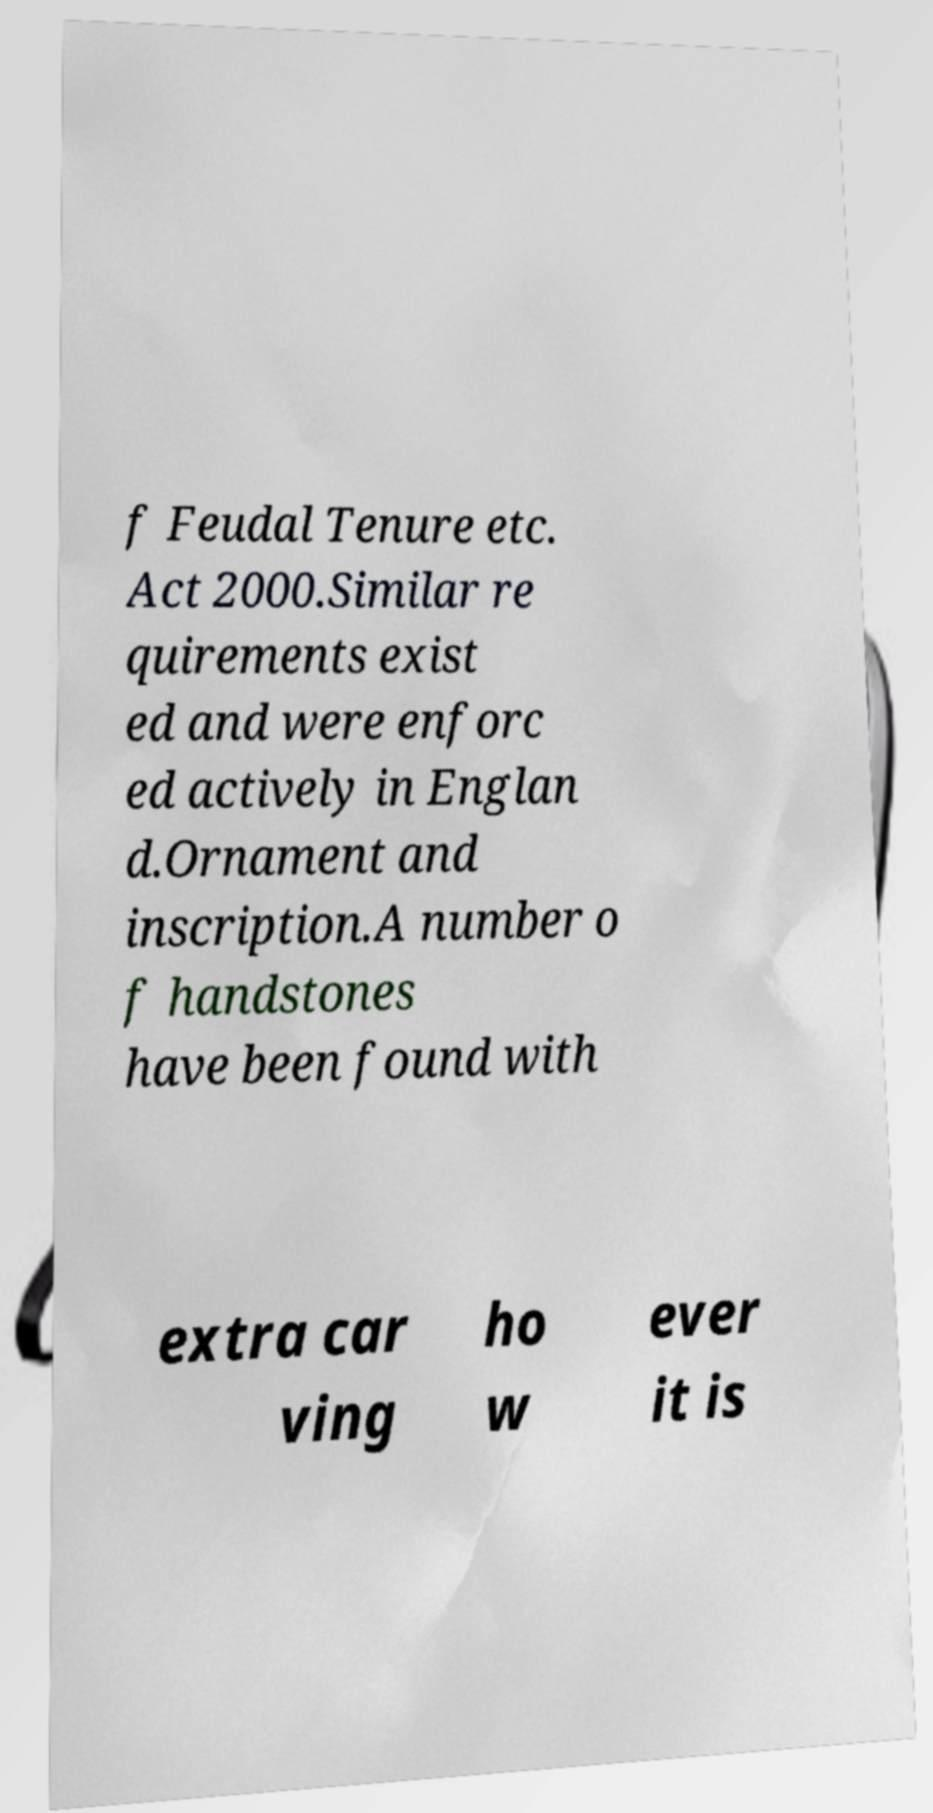What messages or text are displayed in this image? I need them in a readable, typed format. f Feudal Tenure etc. Act 2000.Similar re quirements exist ed and were enforc ed actively in Englan d.Ornament and inscription.A number o f handstones have been found with extra car ving ho w ever it is 